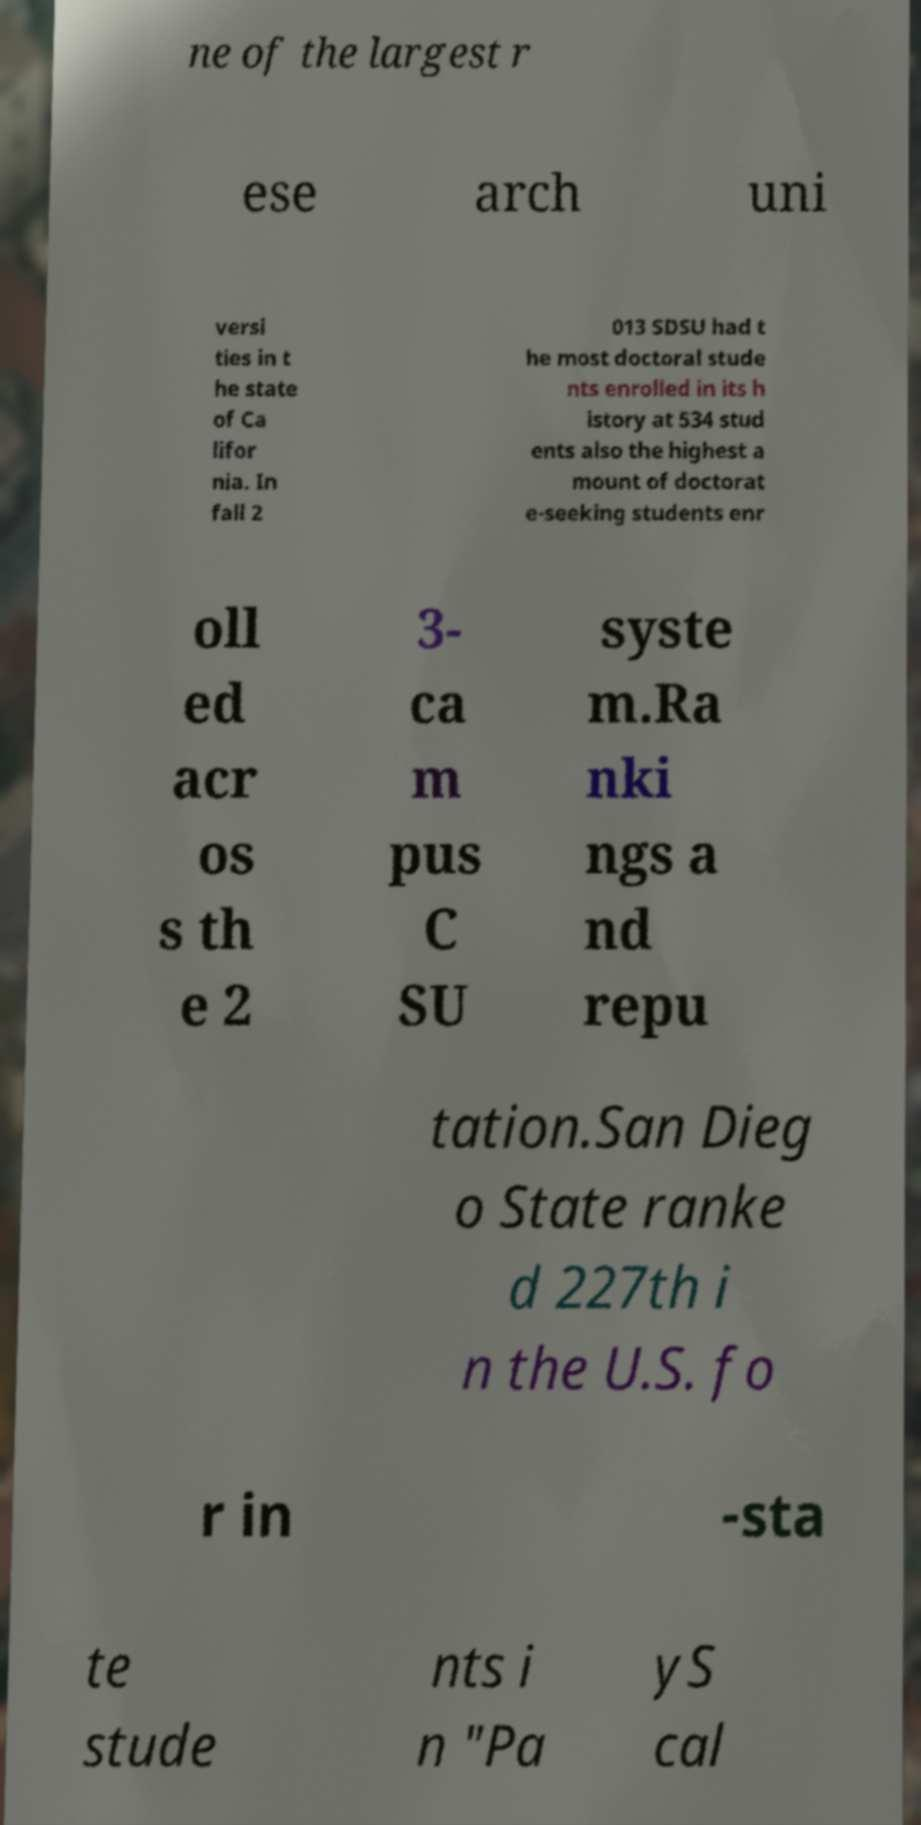For documentation purposes, I need the text within this image transcribed. Could you provide that? ne of the largest r ese arch uni versi ties in t he state of Ca lifor nia. In fall 2 013 SDSU had t he most doctoral stude nts enrolled in its h istory at 534 stud ents also the highest a mount of doctorat e-seeking students enr oll ed acr os s th e 2 3- ca m pus C SU syste m.Ra nki ngs a nd repu tation.San Dieg o State ranke d 227th i n the U.S. fo r in -sta te stude nts i n "Pa yS cal 